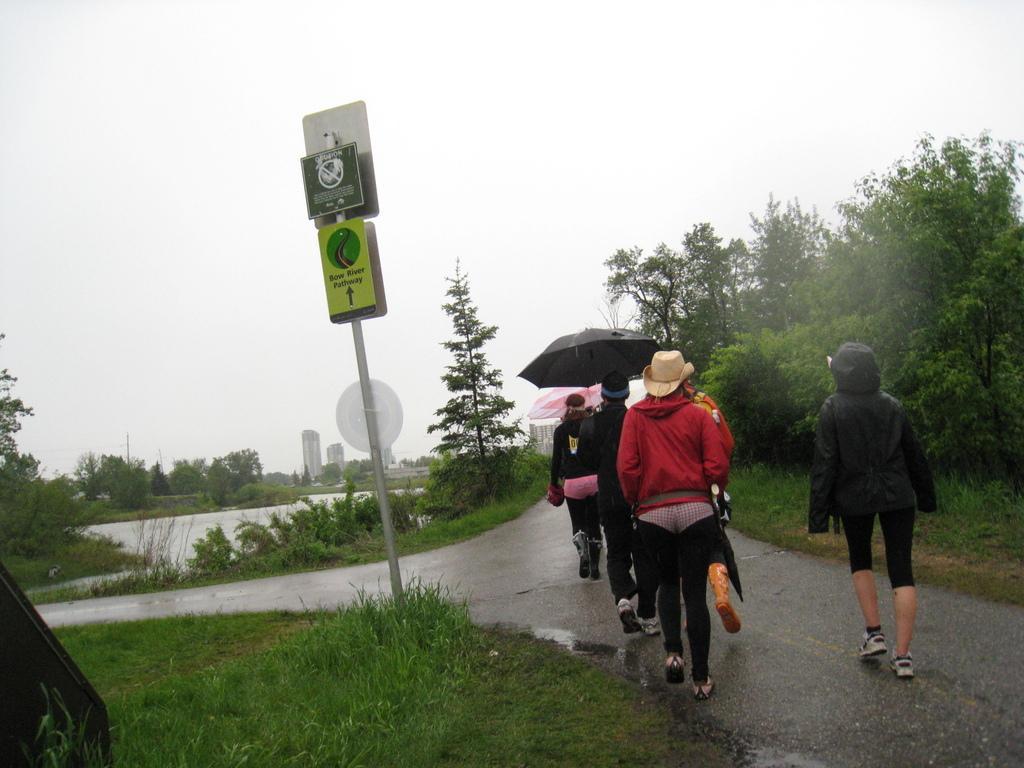How would you summarize this image in a sentence or two? In this image there are so many people walking on the road holding umbrellas, beside them there are so many trees and lake also there is a pole with boards. 